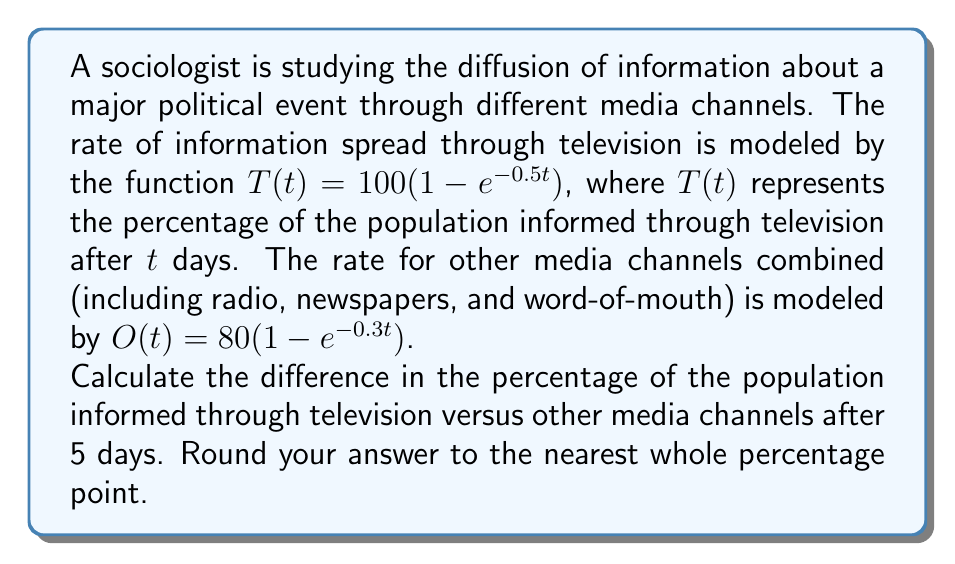Can you answer this question? To solve this problem, we need to follow these steps:

1. Calculate the percentage of the population informed through television after 5 days:
   $$T(5) = 100(1 - e^{-0.5 \cdot 5})$$
   $$T(5) = 100(1 - e^{-2.5})$$
   $$T(5) = 100(1 - 0.0821)$$
   $$T(5) = 100 \cdot 0.9179 = 91.79\%$$

2. Calculate the percentage of the population informed through other media channels after 5 days:
   $$O(5) = 80(1 - e^{-0.3 \cdot 5})$$
   $$O(5) = 80(1 - e^{-1.5})$$
   $$O(5) = 80(1 - 0.2231)$$
   $$O(5) = 80 \cdot 0.7769 = 62.15\%$$

3. Calculate the difference between the two percentages:
   $$\text{Difference} = T(5) - O(5)$$
   $$\text{Difference} = 91.79\% - 62.15\% = 29.64\%$$

4. Round the result to the nearest whole percentage point:
   29.64% rounds to 30%

This calculation demonstrates that after 5 days, television had informed a significantly larger percentage of the population compared to other media channels combined, supporting the sociology professor's belief in the decisive impact of television in the late 20th century.
Answer: 30% 